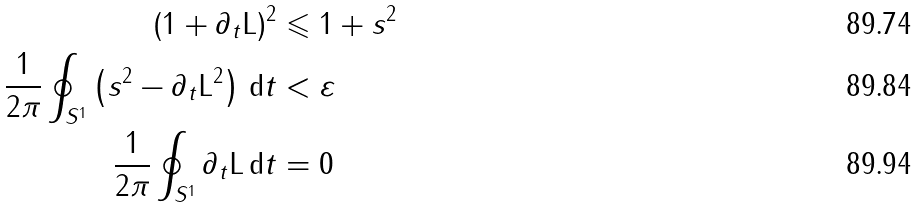Convert formula to latex. <formula><loc_0><loc_0><loc_500><loc_500>( 1 + \partial _ { t } \mathrm L ) ^ { 2 } & \leqslant 1 + s ^ { 2 } \\ \frac { 1 } { 2 \pi } \oint _ { S ^ { 1 } } \left ( s ^ { 2 } - \partial _ { t } \mathrm L ^ { 2 } \right ) \, \mathrm d t & < \varepsilon \\ \frac { 1 } { 2 \pi } \oint _ { S ^ { 1 } } \partial _ { t } \mathrm L \, \mathrm d t & = 0</formula> 